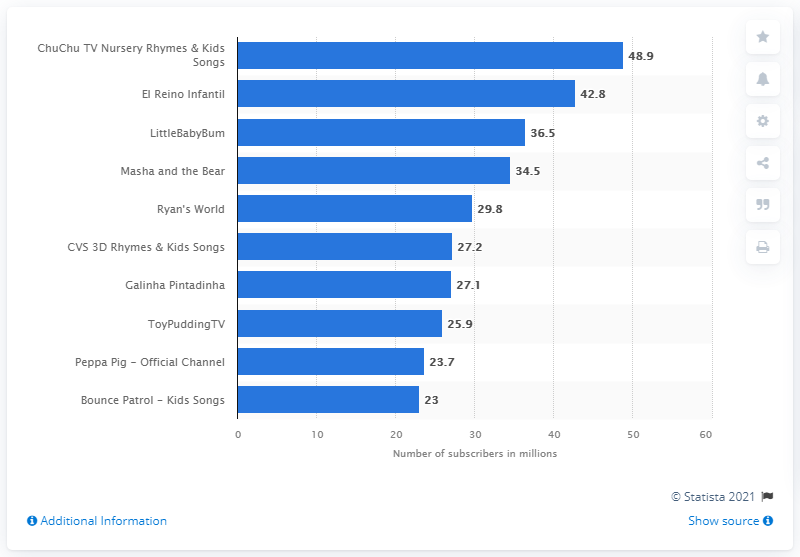List a handful of essential elements in this visual. As of May 2021, ChuChu TV Nursery Rhymes & Kids Songs had approximately 48.9 subscribers. As of May 2021, ChuChu TV Nursery Rhymes & Kids Songs was the most subscribed kids content channel on YouTube. 